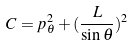<formula> <loc_0><loc_0><loc_500><loc_500>C = p _ { \theta } ^ { 2 } + ( \frac { L } { \sin \theta } ) ^ { 2 }</formula> 